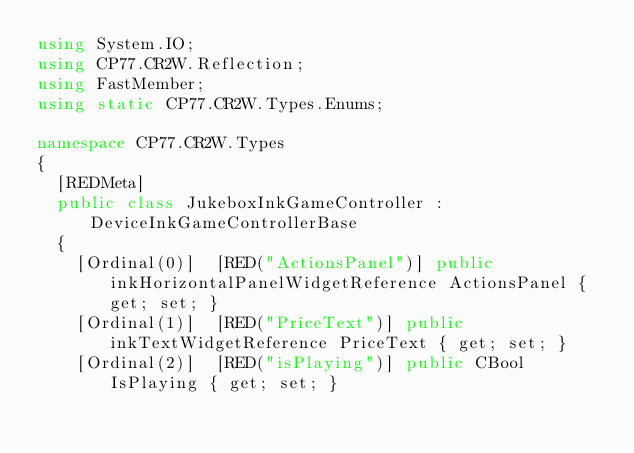<code> <loc_0><loc_0><loc_500><loc_500><_C#_>using System.IO;
using CP77.CR2W.Reflection;
using FastMember;
using static CP77.CR2W.Types.Enums;

namespace CP77.CR2W.Types
{
	[REDMeta]
	public class JukeboxInkGameController : DeviceInkGameControllerBase
	{
		[Ordinal(0)]  [RED("ActionsPanel")] public inkHorizontalPanelWidgetReference ActionsPanel { get; set; }
		[Ordinal(1)]  [RED("PriceText")] public inkTextWidgetReference PriceText { get; set; }
		[Ordinal(2)]  [RED("isPlaying")] public CBool IsPlaying { get; set; }</code> 